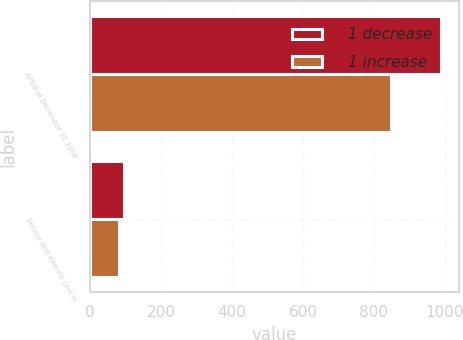<chart> <loc_0><loc_0><loc_500><loc_500><stacked_bar_chart><ecel><fcel>APBO at December 31 2008<fcel>Service and interest cost in<nl><fcel>1 decrease<fcel>990<fcel>95<nl><fcel>1 increase<fcel>848<fcel>80<nl></chart> 